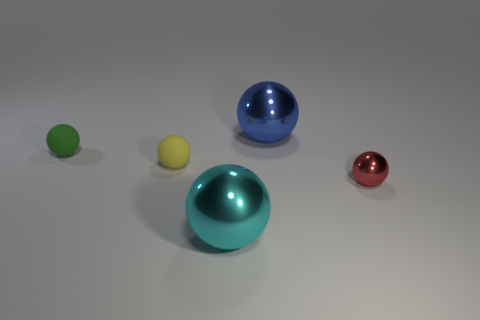Subtract all red balls. Subtract all cyan cubes. How many balls are left? 4 Add 3 small purple rubber objects. How many objects exist? 8 Subtract all metallic things. Subtract all gray rubber cylinders. How many objects are left? 2 Add 5 tiny red objects. How many tiny red objects are left? 6 Add 1 large purple matte balls. How many large purple matte balls exist? 1 Subtract 0 brown cylinders. How many objects are left? 5 